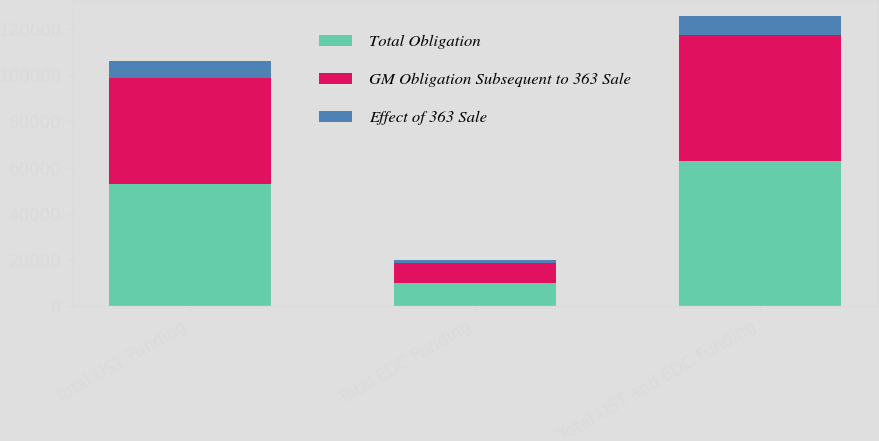Convert chart to OTSL. <chart><loc_0><loc_0><loc_500><loc_500><stacked_bar_chart><ecel><fcel>Total UST Funding<fcel>Total EDC Funding<fcel>Total UST and EDC Funding<nl><fcel>Total Obligation<fcel>53041<fcel>9868<fcel>62909<nl><fcel>GM Obligation Subsequent to 363 Sale<fcel>45968<fcel>8576<fcel>54544<nl><fcel>Effect of 363 Sale<fcel>7073<fcel>1292<fcel>8365<nl></chart> 